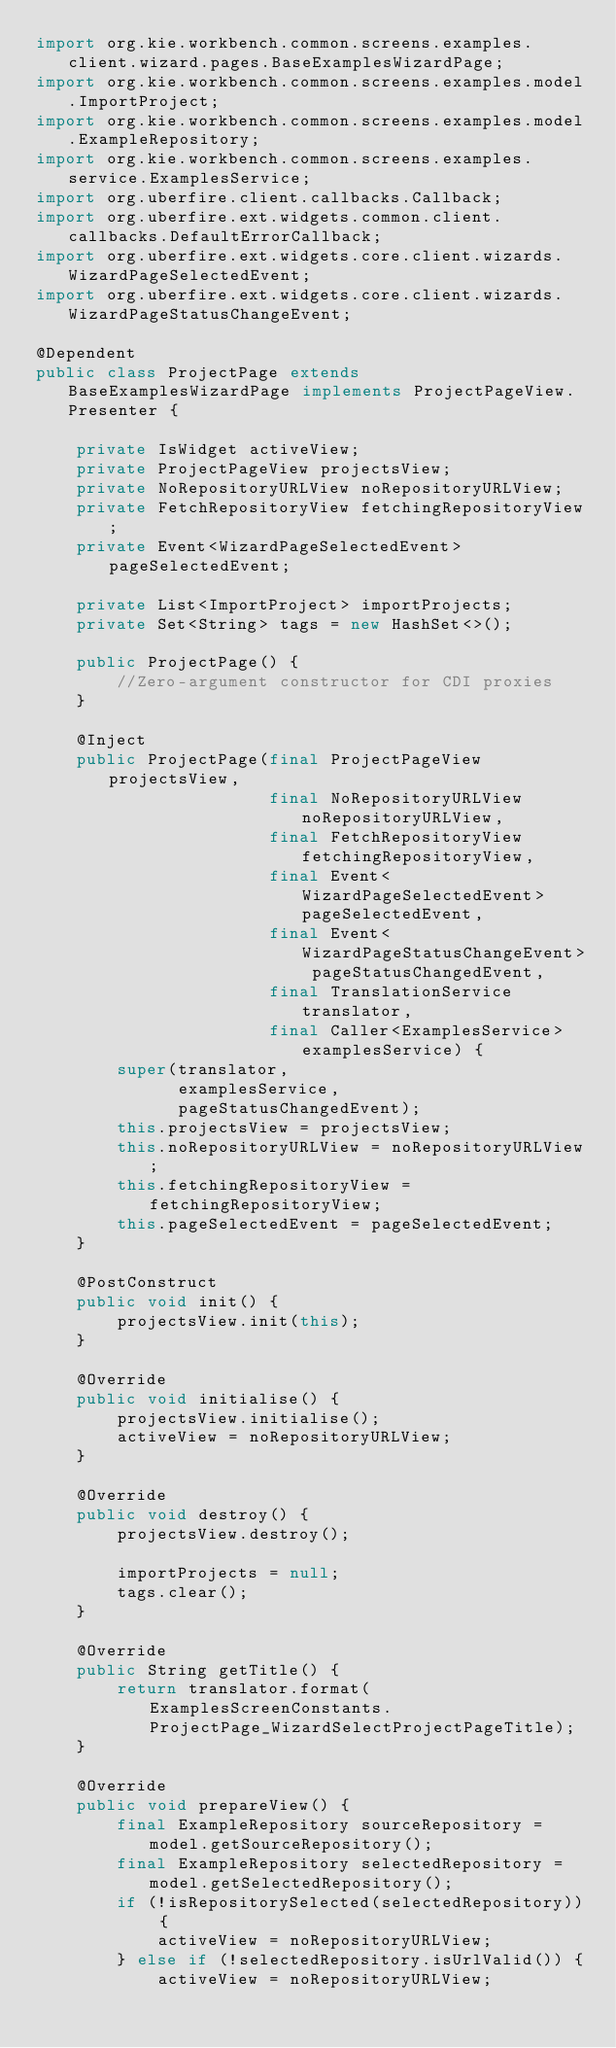Convert code to text. <code><loc_0><loc_0><loc_500><loc_500><_Java_>import org.kie.workbench.common.screens.examples.client.wizard.pages.BaseExamplesWizardPage;
import org.kie.workbench.common.screens.examples.model.ImportProject;
import org.kie.workbench.common.screens.examples.model.ExampleRepository;
import org.kie.workbench.common.screens.examples.service.ExamplesService;
import org.uberfire.client.callbacks.Callback;
import org.uberfire.ext.widgets.common.client.callbacks.DefaultErrorCallback;
import org.uberfire.ext.widgets.core.client.wizards.WizardPageSelectedEvent;
import org.uberfire.ext.widgets.core.client.wizards.WizardPageStatusChangeEvent;

@Dependent
public class ProjectPage extends BaseExamplesWizardPage implements ProjectPageView.Presenter {

    private IsWidget activeView;
    private ProjectPageView projectsView;
    private NoRepositoryURLView noRepositoryURLView;
    private FetchRepositoryView fetchingRepositoryView;
    private Event<WizardPageSelectedEvent> pageSelectedEvent;

    private List<ImportProject> importProjects;
    private Set<String> tags = new HashSet<>();

    public ProjectPage() {
        //Zero-argument constructor for CDI proxies
    }

    @Inject
    public ProjectPage(final ProjectPageView projectsView,
                       final NoRepositoryURLView noRepositoryURLView,
                       final FetchRepositoryView fetchingRepositoryView,
                       final Event<WizardPageSelectedEvent> pageSelectedEvent,
                       final Event<WizardPageStatusChangeEvent> pageStatusChangedEvent,
                       final TranslationService translator,
                       final Caller<ExamplesService> examplesService) {
        super(translator,
              examplesService,
              pageStatusChangedEvent);
        this.projectsView = projectsView;
        this.noRepositoryURLView = noRepositoryURLView;
        this.fetchingRepositoryView = fetchingRepositoryView;
        this.pageSelectedEvent = pageSelectedEvent;
    }

    @PostConstruct
    public void init() {
        projectsView.init(this);
    }

    @Override
    public void initialise() {
        projectsView.initialise();
        activeView = noRepositoryURLView;
    }

    @Override
    public void destroy() {
        projectsView.destroy();

        importProjects = null;
        tags.clear();
    }

    @Override
    public String getTitle() {
        return translator.format(ExamplesScreenConstants.ProjectPage_WizardSelectProjectPageTitle);
    }

    @Override
    public void prepareView() {
        final ExampleRepository sourceRepository = model.getSourceRepository();
        final ExampleRepository selectedRepository = model.getSelectedRepository();
        if (!isRepositorySelected(selectedRepository)) {
            activeView = noRepositoryURLView;
        } else if (!selectedRepository.isUrlValid()) {
            activeView = noRepositoryURLView;</code> 